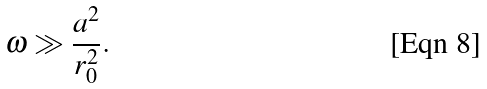<formula> <loc_0><loc_0><loc_500><loc_500>\omega \gg \frac { a ^ { 2 } } { r _ { 0 } ^ { 2 } } .</formula> 